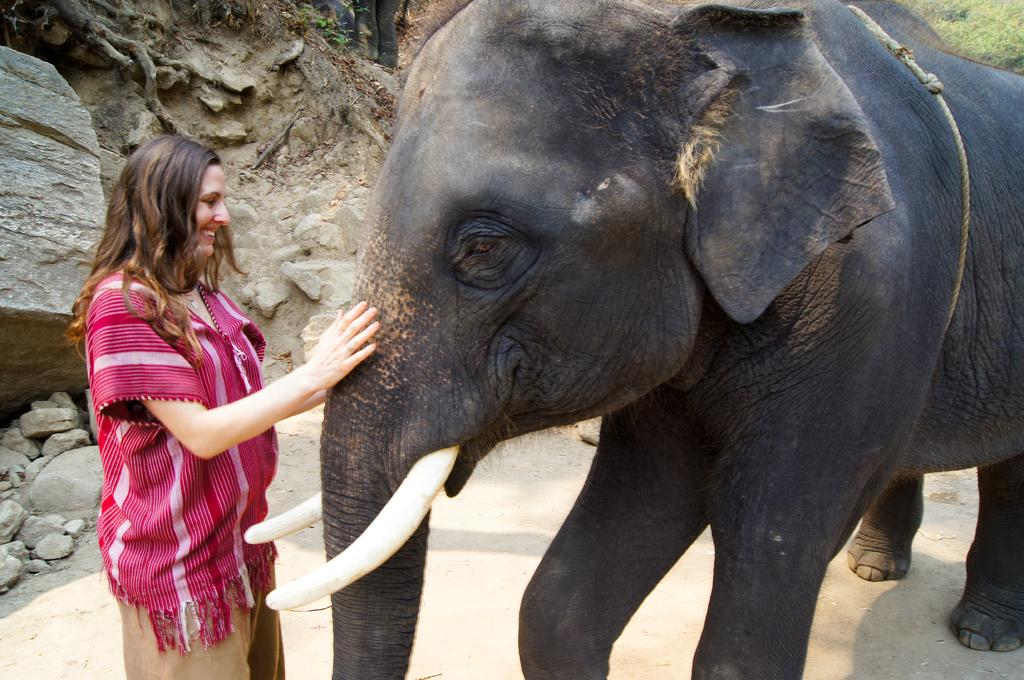What is the main subject of the image? The main subject of the image is a woman. What is the woman doing in the image? The woman is standing and touching an elephant. What is the woman's facial expression in the image? The woman is smiling. What can be seen in the background of the image? There is a hill visible in the background of the image. Can you tell me how much honey the goose is carrying in the image? There is no goose or honey present in the image. 